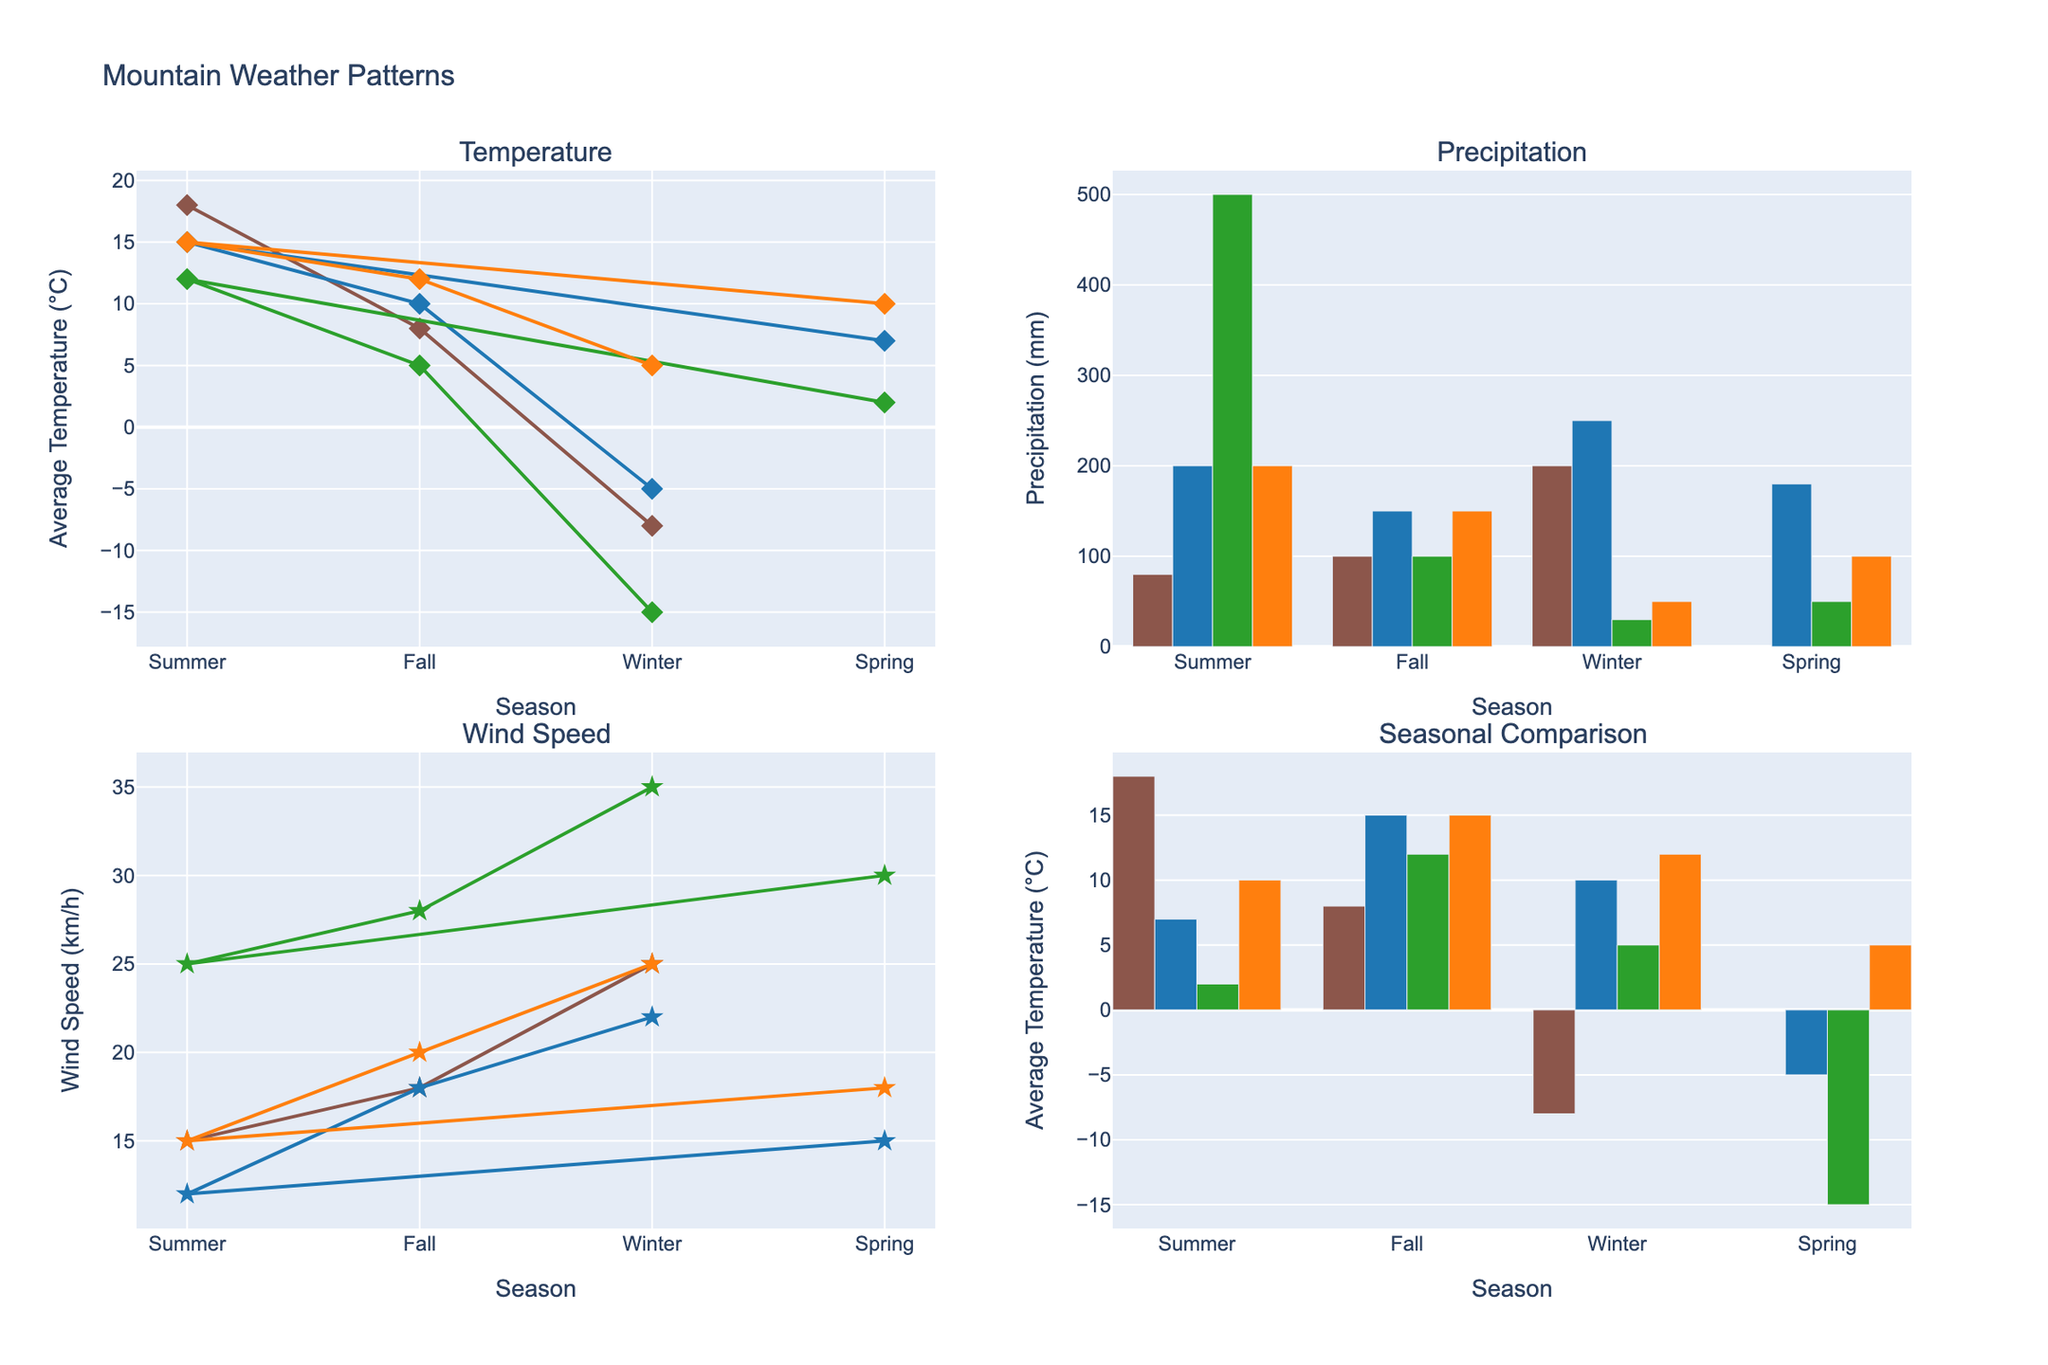Which region has the lowest average temperature in Winter? To determine the region with the lowest average temperature in Winter, look at the Temperature subplot and observe the Winter data points. The Himalayas have the lowest average temperature at -15°C.
Answer: The Himalayas Which season has the highest precipitation in the Alps? Locate the Precipitation subplot and look for the bars representing each season for the Alps. The Winter season has the highest precipitation level at 250 mm.
Answer: Winter Compare the average temperatures in the Rockies and the Andes during Summer. Which is higher? In the Temperature subplot, compare the data points for the Rockies and the Andes during Summer. The Rockies have an average temperature of 18°C, while the Andes have an average temperature of 15°C. The Rockies have a higher average temperature.
Answer: The Rockies By how many millimeters does the precipitation in the Himalayas during Summer exceed that in Spring? Check the Precipitation subplot for the Himalayas' bars during Summer and Spring. The Summer precipitation is 500 mm, and Spring is 50 mm. The difference is 500 - 50 = 450 mm.
Answer: 450 mm What's the average wind speed of the Rocky Mountains across all seasons? To find the average, sum the Rocky Mountains' wind speeds from the Wind Speed subplot: 15 (Summer) + 18 (Fall) + 25 (Winter) = 58 and count the seasons (4). Divide the total by the number of seasons: 58 / 3 = 19.33 km/h.
Answer: 19.33 km/h Among the four regions, which has the least variation in temperature across all seasons? Analyze the Temperature subplot for each region's temperature range (max temp - min temp). The Andes show the least variation from 5°C (Winter) to 15°C (Summer), a range of 10°C.
Answer: The Andes Which region experiences the highest wind speed and in which season? In the Wind Speed subplot, locate the highest data point, which appears in the Himalayas during Winter with a wind speed of 35 km/h.
Answer: The Himalayas, Winter What is the average precipitation in the Alps for Spring and Fall? From the Precipitation subplot, find the Alpine precipitation values for Spring (180 mm) and Fall (150 mm). Calculate the average: (180 + 150) / 2 = 165 mm.
Answer: 165 mm Is the average temperature during Summer in the Alps higher than in the Himalayas? Compare the Summer data points from the Temperature subplot for Alps and Himalayas. The Alps have 15°C, while Himalayas have 12°C. The Alps have the higher average temperature.
Answer: Yes 